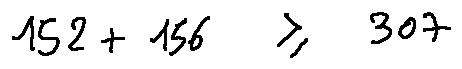<formula> <loc_0><loc_0><loc_500><loc_500>1 5 2 + 1 5 6 \geq 3 0 7</formula> 